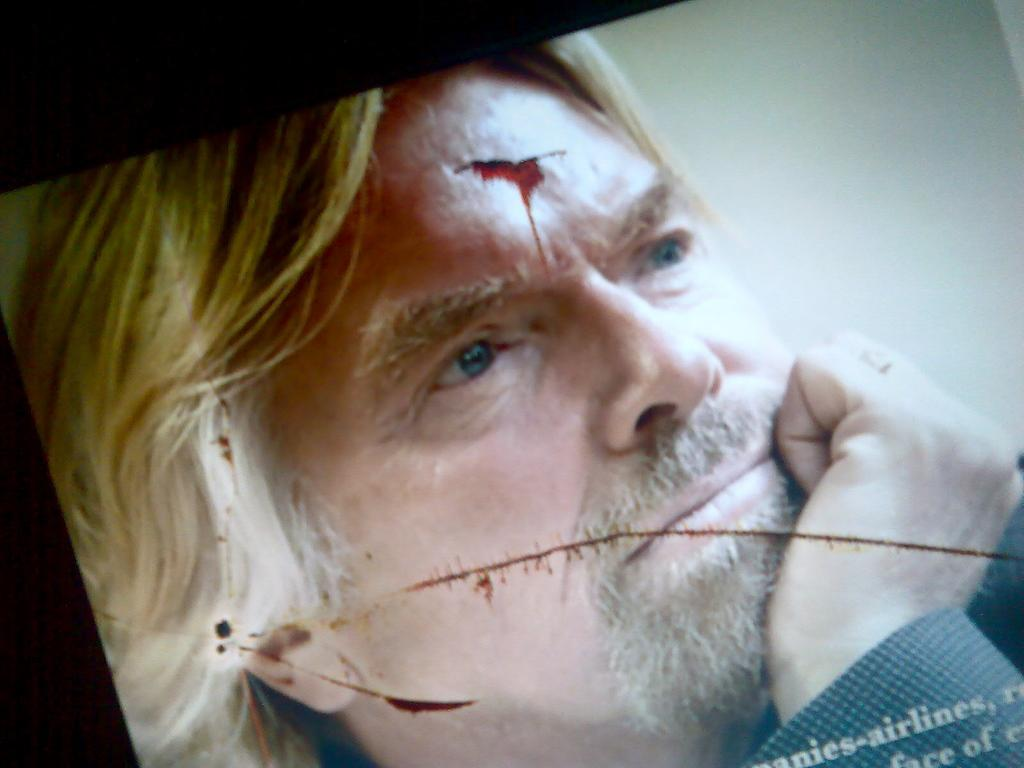What is the main subject of the image? The main subject of the image is the face of a person. What type of cracker is being eaten by the insect on the lettuce in the image? There is no cracker, insect, or lettuce present in the image; it only features the face of a person. 